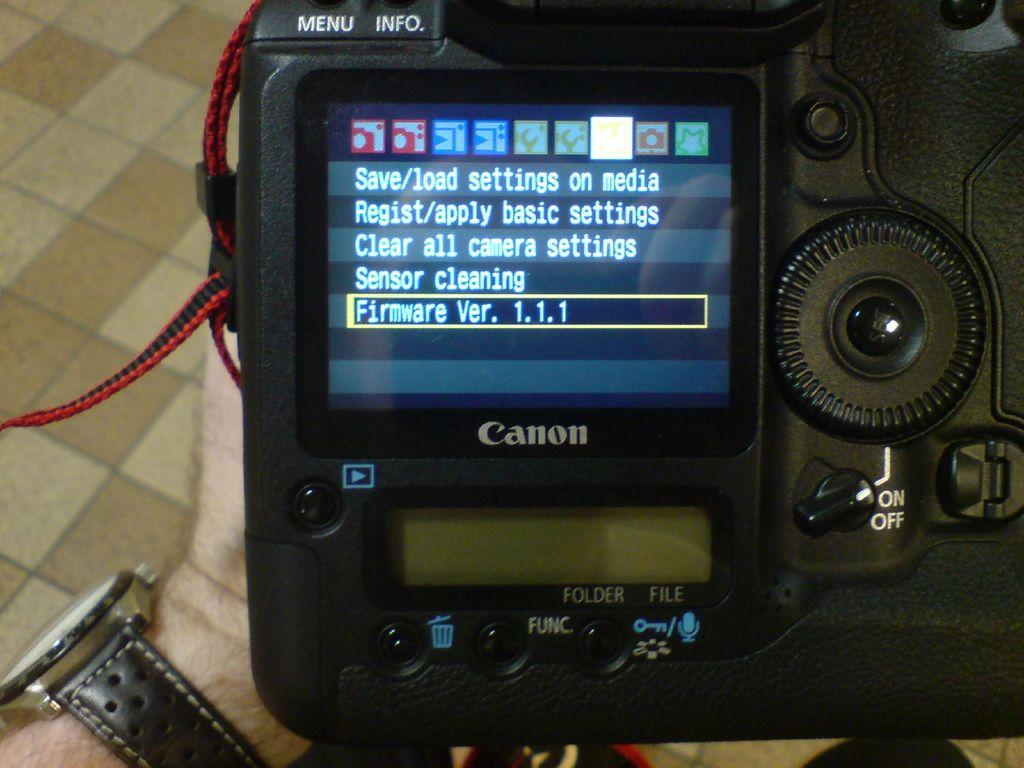<image>
Describe the image concisely. The settngs screen to a Canon branded digital camera. 